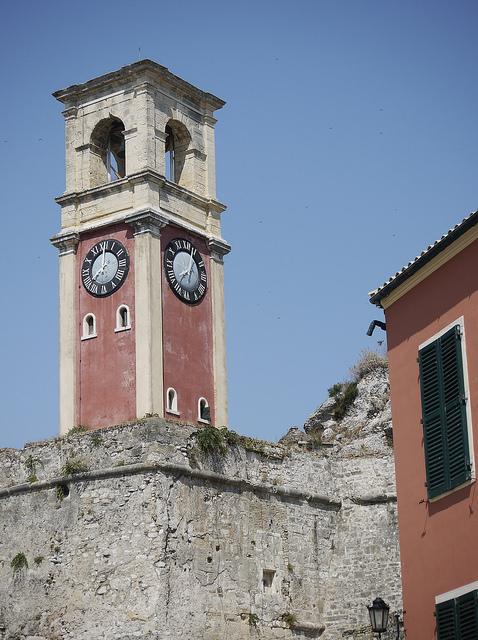How many windows are in the picture?
Short answer required. 6. What is the color of the house?
Answer briefly. Red. How many clocks are in the photo?
Keep it brief. 2. Is there a bell in the tower?
Answer briefly. Yes. Are there any clouds in the sky?
Write a very short answer. No. 